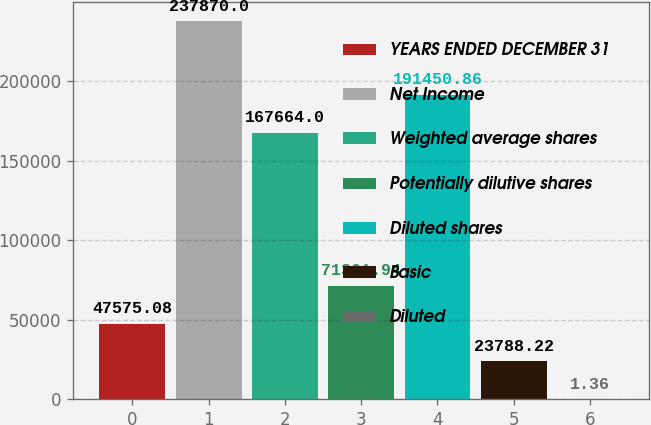Convert chart. <chart><loc_0><loc_0><loc_500><loc_500><bar_chart><fcel>YEARS ENDED DECEMBER 31<fcel>Net Income<fcel>Weighted average shares<fcel>Potentially dilutive shares<fcel>Diluted shares<fcel>Basic<fcel>Diluted<nl><fcel>47575.1<fcel>237870<fcel>167664<fcel>71361.9<fcel>191451<fcel>23788.2<fcel>1.36<nl></chart> 